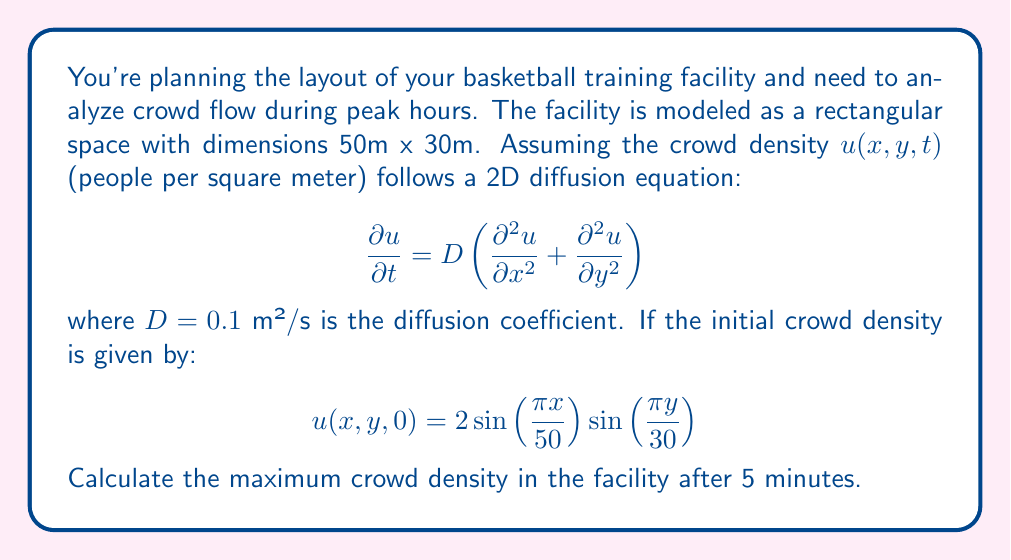Help me with this question. To solve this problem, we need to use the separation of variables method for the 2D diffusion equation.

1) First, we assume a solution of the form:
   $$u(x,y,t) = X(x)Y(y)T(t)$$

2) Substituting this into the diffusion equation and separating variables:
   $$\frac{T'(t)}{DT(t)} = \frac{X''(x)}{X(x)} + \frac{Y''(y)}{Y(y)} = -k^2$$

   where $k^2$ is a separation constant.

3) This leads to three ODEs:
   $$T'(t) = -Dk^2T(t)$$
   $$X''(x) + \lambda^2X(x) = 0$$
   $$Y''(y) + \mu^2Y(y) = 0$$

   where $k^2 = \lambda^2 + \mu^2$

4) Given the initial condition, we can deduce:
   $$\lambda = \frac{\pi}{50}, \mu = \frac{\pi}{30}$$

5) The general solution is:
   $$u(x,y,t) = Ae^{-Dk^2t}\sin(\lambda x)\sin(\mu y)$$

   where $k^2 = (\frac{\pi}{50})^2 + (\frac{\pi}{30})^2$

6) Using the initial condition to find $A$:
   $$u(x,y,0) = 2\sin(\frac{\pi x}{50})\sin(\frac{\pi y}{30})$$
   Therefore, $A = 2$

7) The solution is:
   $$u(x,y,t) = 2e^{-Dk^2t}\sin(\frac{\pi x}{50})\sin(\frac{\pi y}{30})$$

8) After 5 minutes (300 seconds), the maximum density occurs at the same location as the initial maximum (at $x=25$, $y=15$):
   $$u_{max}(300) = 2e^{-0.1 \cdot ((\frac{\pi}{50})^2 + (\frac{\pi}{30})^2) \cdot 300}$$

9) Calculate the exponent:
   $$(\frac{\pi}{50})^2 + (\frac{\pi}{30})^2 \approx 0.0197$$
   $$0.1 \cdot 0.0197 \cdot 300 \approx 0.591$$

10) Therefore:
    $$u_{max}(300) = 2e^{-0.591} \approx 1.108$$
Answer: The maximum crowd density after 5 minutes is approximately 1.108 people per square meter. 